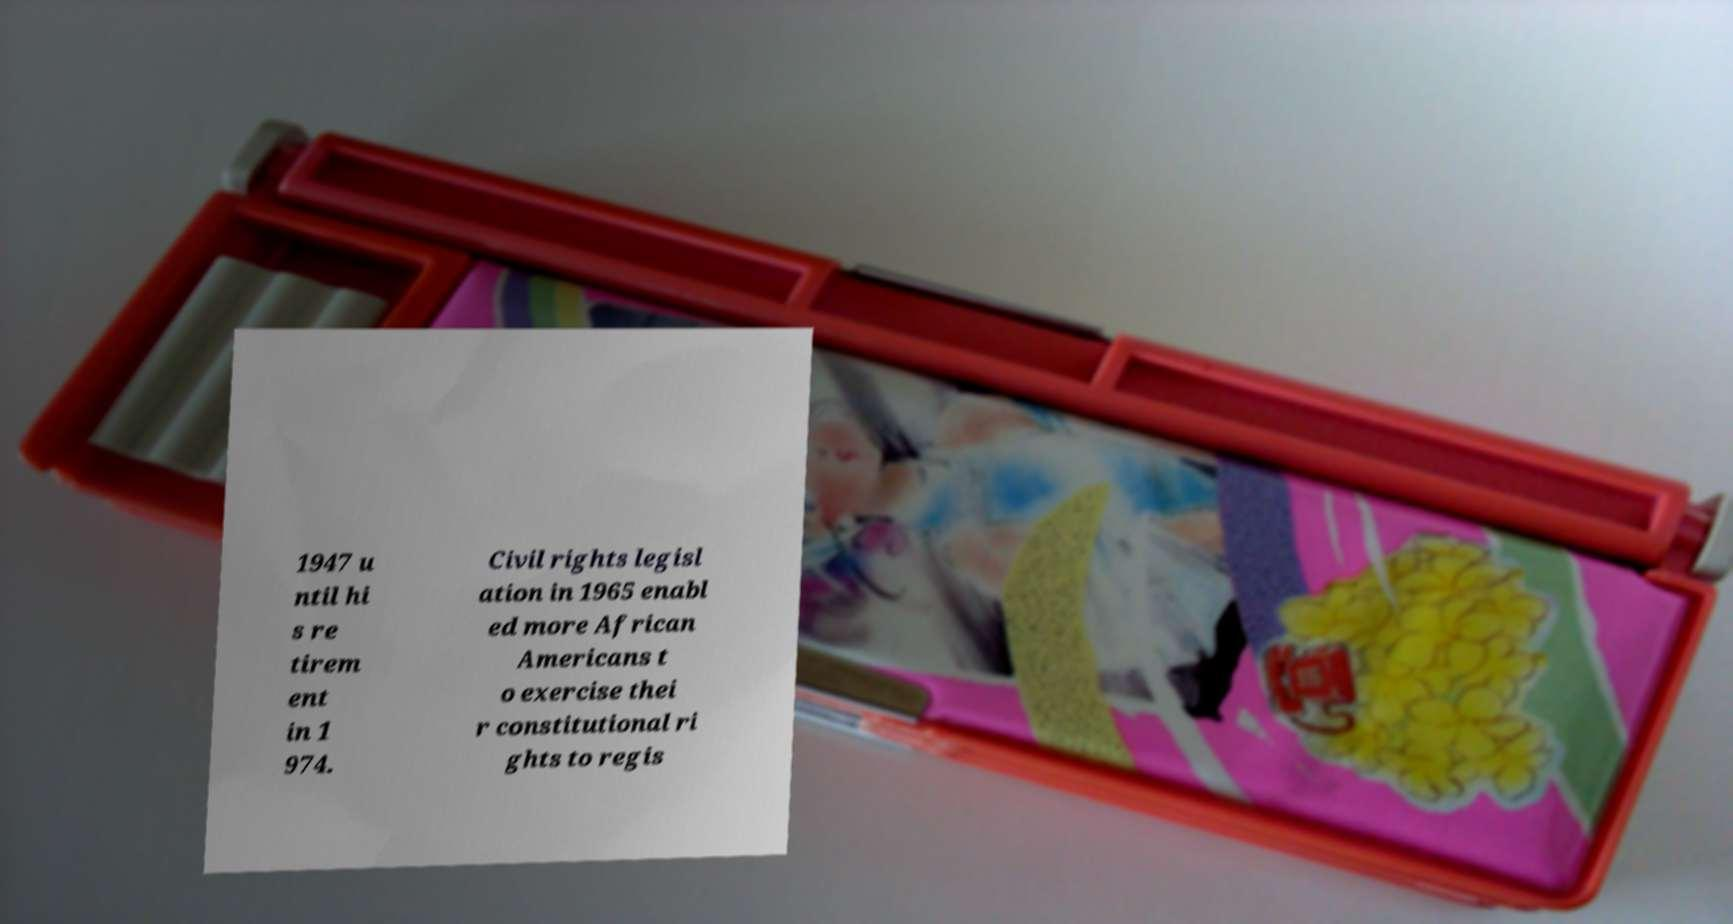For documentation purposes, I need the text within this image transcribed. Could you provide that? 1947 u ntil hi s re tirem ent in 1 974. Civil rights legisl ation in 1965 enabl ed more African Americans t o exercise thei r constitutional ri ghts to regis 